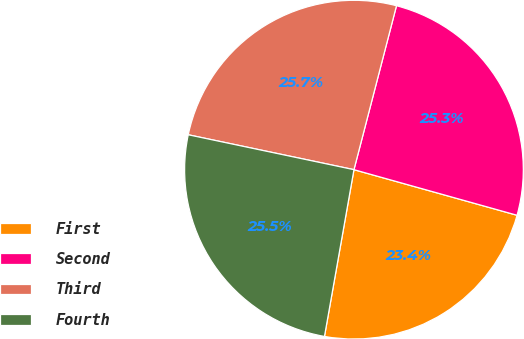Convert chart. <chart><loc_0><loc_0><loc_500><loc_500><pie_chart><fcel>First<fcel>Second<fcel>Third<fcel>Fourth<nl><fcel>23.45%<fcel>25.3%<fcel>25.74%<fcel>25.52%<nl></chart> 